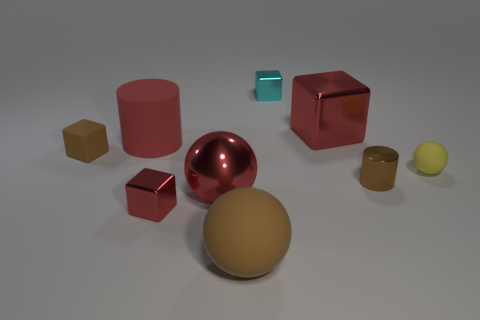Does the small metallic cylinder have the same color as the large matte sphere?
Your response must be concise. Yes. Are there fewer small cylinders behind the yellow matte ball than tiny red blocks that are in front of the brown cube?
Provide a short and direct response. Yes. How big is the red rubber cylinder?
Your answer should be very brief. Large. How many tiny objects are either blocks or cyan cubes?
Ensure brevity in your answer.  3. There is a yellow matte object; is it the same size as the block that is in front of the yellow rubber sphere?
Make the answer very short. Yes. What number of yellow rubber cubes are there?
Offer a terse response. 0. How many yellow objects are either tiny metal things or large shiny spheres?
Give a very brief answer. 0. Is the material of the sphere that is left of the large brown rubber thing the same as the tiny cyan thing?
Offer a terse response. Yes. How many other objects are there of the same material as the big cylinder?
Offer a terse response. 3. What material is the small red cube?
Make the answer very short. Metal. 